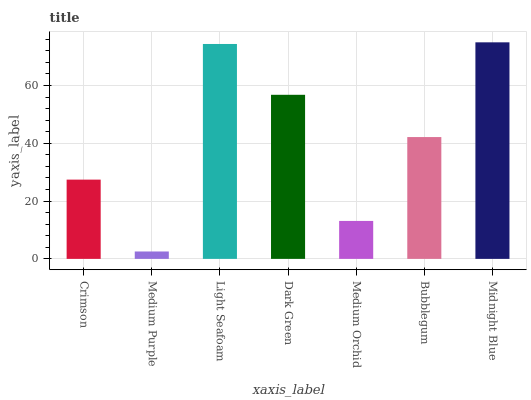Is Light Seafoam the minimum?
Answer yes or no. No. Is Light Seafoam the maximum?
Answer yes or no. No. Is Light Seafoam greater than Medium Purple?
Answer yes or no. Yes. Is Medium Purple less than Light Seafoam?
Answer yes or no. Yes. Is Medium Purple greater than Light Seafoam?
Answer yes or no. No. Is Light Seafoam less than Medium Purple?
Answer yes or no. No. Is Bubblegum the high median?
Answer yes or no. Yes. Is Bubblegum the low median?
Answer yes or no. Yes. Is Crimson the high median?
Answer yes or no. No. Is Light Seafoam the low median?
Answer yes or no. No. 